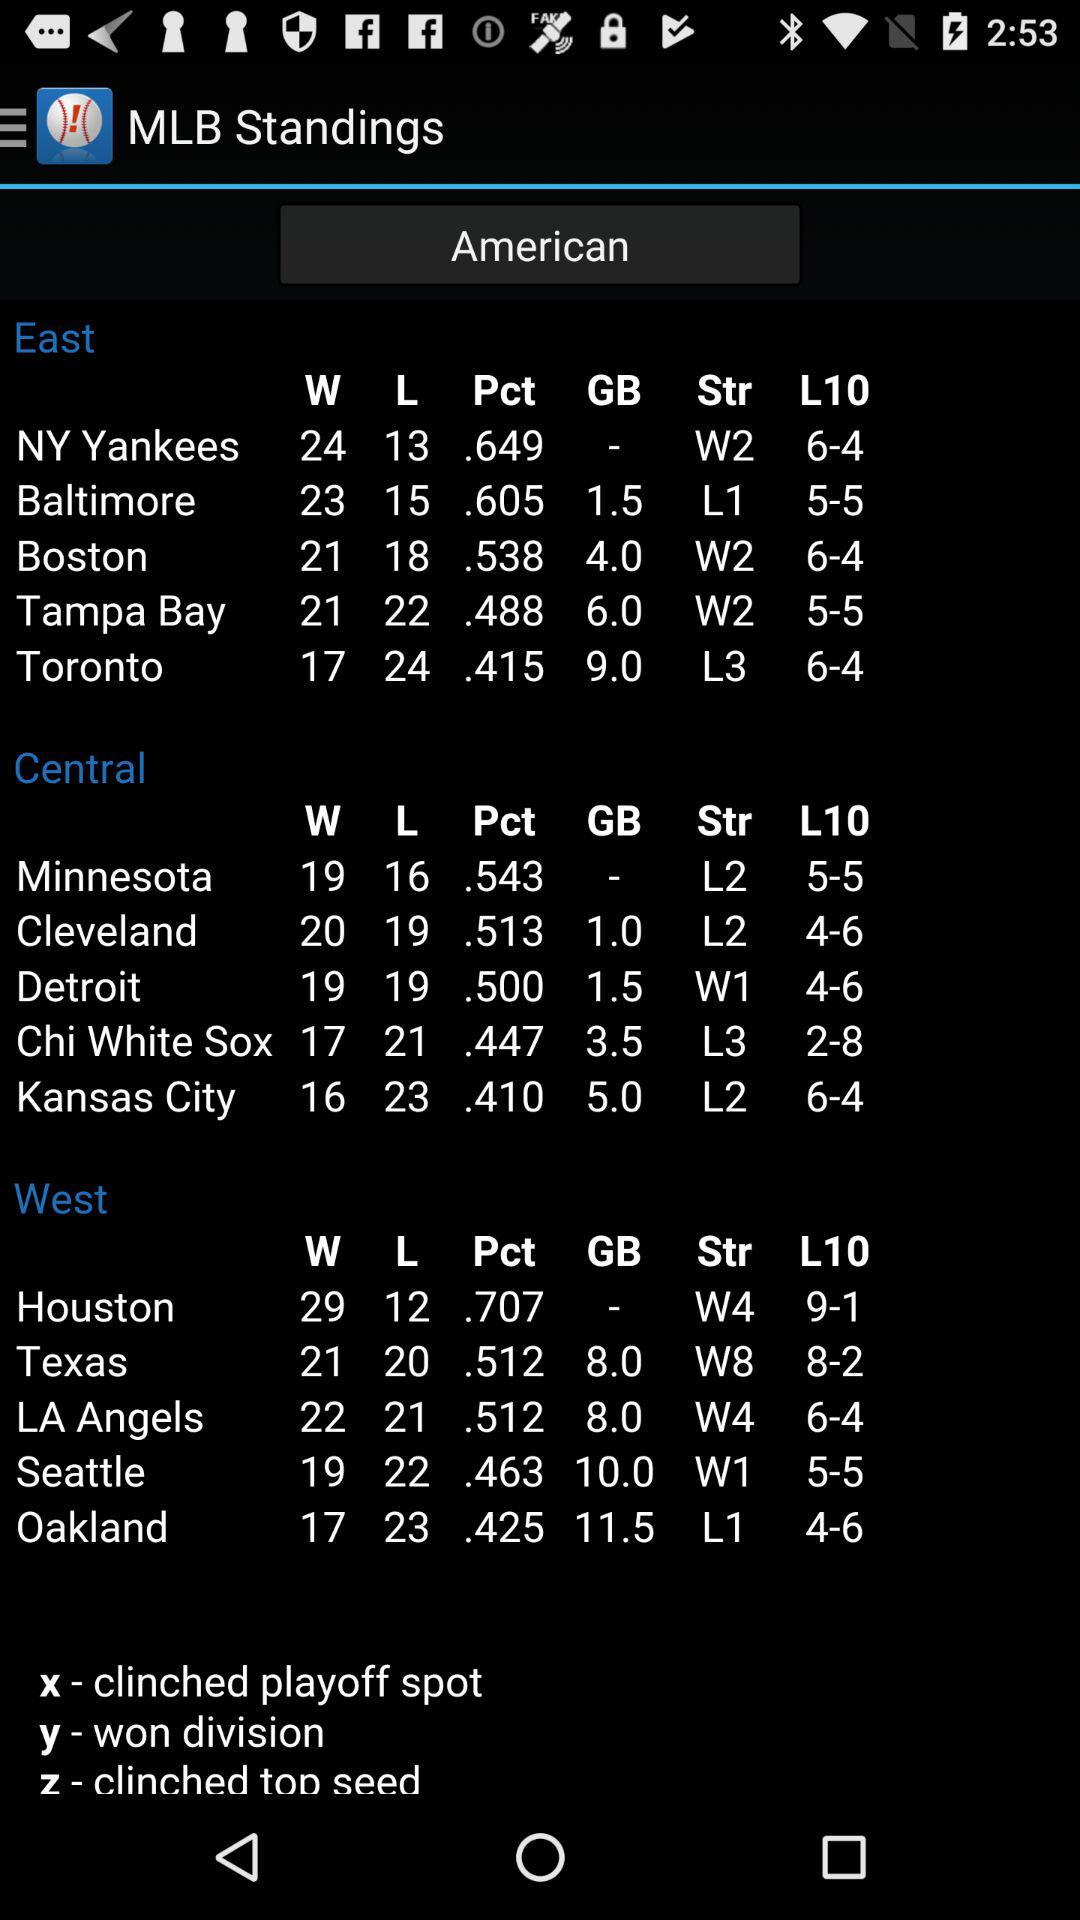How many divisions are there in the MLB Standings?
When the provided information is insufficient, respond with <no answer>. <no answer> 